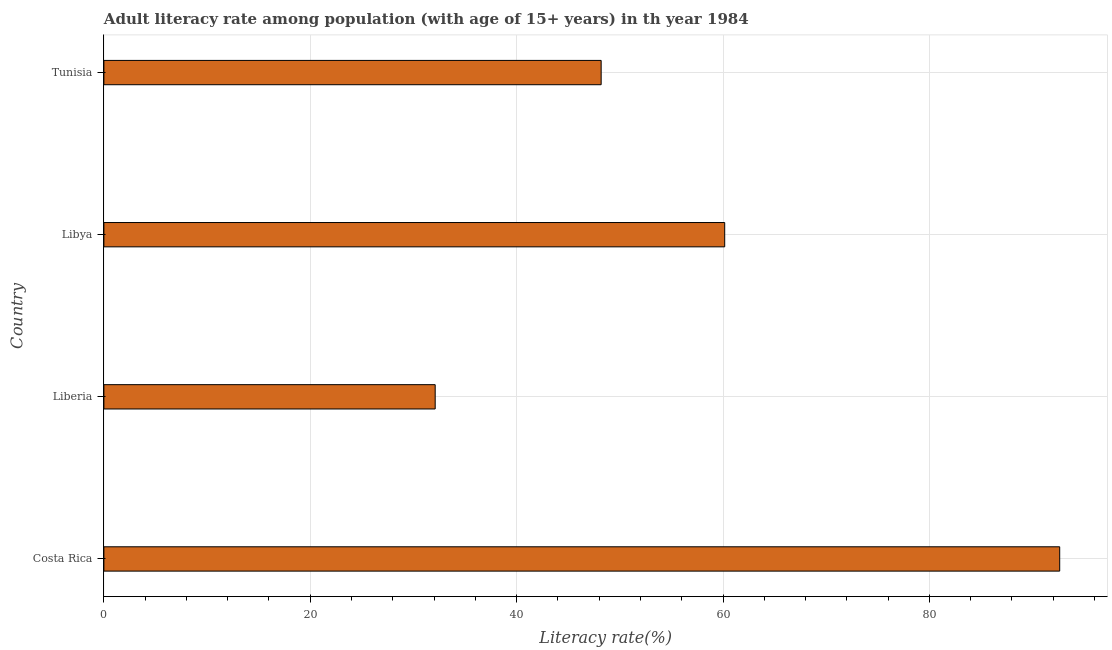What is the title of the graph?
Provide a short and direct response. Adult literacy rate among population (with age of 15+ years) in th year 1984. What is the label or title of the X-axis?
Offer a very short reply. Literacy rate(%). What is the label or title of the Y-axis?
Offer a very short reply. Country. What is the adult literacy rate in Liberia?
Your answer should be compact. 32.11. Across all countries, what is the maximum adult literacy rate?
Provide a short and direct response. 92.63. Across all countries, what is the minimum adult literacy rate?
Your answer should be very brief. 32.11. In which country was the adult literacy rate maximum?
Give a very brief answer. Costa Rica. In which country was the adult literacy rate minimum?
Provide a succinct answer. Liberia. What is the sum of the adult literacy rate?
Make the answer very short. 233.09. What is the difference between the adult literacy rate in Liberia and Tunisia?
Offer a terse response. -16.08. What is the average adult literacy rate per country?
Your answer should be compact. 58.27. What is the median adult literacy rate?
Your answer should be very brief. 54.18. What is the ratio of the adult literacy rate in Costa Rica to that in Tunisia?
Make the answer very short. 1.92. Is the adult literacy rate in Liberia less than that in Tunisia?
Give a very brief answer. Yes. What is the difference between the highest and the second highest adult literacy rate?
Offer a terse response. 32.47. Is the sum of the adult literacy rate in Liberia and Libya greater than the maximum adult literacy rate across all countries?
Your answer should be compact. No. What is the difference between the highest and the lowest adult literacy rate?
Your answer should be compact. 60.52. How many bars are there?
Provide a short and direct response. 4. Are all the bars in the graph horizontal?
Your answer should be very brief. Yes. What is the difference between two consecutive major ticks on the X-axis?
Give a very brief answer. 20. Are the values on the major ticks of X-axis written in scientific E-notation?
Ensure brevity in your answer.  No. What is the Literacy rate(%) in Costa Rica?
Your answer should be compact. 92.63. What is the Literacy rate(%) in Liberia?
Offer a terse response. 32.11. What is the Literacy rate(%) of Libya?
Offer a terse response. 60.16. What is the Literacy rate(%) of Tunisia?
Keep it short and to the point. 48.19. What is the difference between the Literacy rate(%) in Costa Rica and Liberia?
Provide a short and direct response. 60.52. What is the difference between the Literacy rate(%) in Costa Rica and Libya?
Keep it short and to the point. 32.46. What is the difference between the Literacy rate(%) in Costa Rica and Tunisia?
Make the answer very short. 44.44. What is the difference between the Literacy rate(%) in Liberia and Libya?
Provide a short and direct response. -28.06. What is the difference between the Literacy rate(%) in Liberia and Tunisia?
Offer a terse response. -16.08. What is the difference between the Literacy rate(%) in Libya and Tunisia?
Give a very brief answer. 11.97. What is the ratio of the Literacy rate(%) in Costa Rica to that in Liberia?
Provide a short and direct response. 2.88. What is the ratio of the Literacy rate(%) in Costa Rica to that in Libya?
Keep it short and to the point. 1.54. What is the ratio of the Literacy rate(%) in Costa Rica to that in Tunisia?
Give a very brief answer. 1.92. What is the ratio of the Literacy rate(%) in Liberia to that in Libya?
Ensure brevity in your answer.  0.53. What is the ratio of the Literacy rate(%) in Liberia to that in Tunisia?
Your answer should be very brief. 0.67. What is the ratio of the Literacy rate(%) in Libya to that in Tunisia?
Offer a terse response. 1.25. 